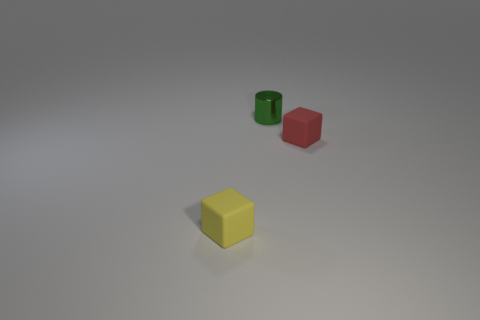What number of other things are the same shape as the green metallic thing?
Your answer should be very brief. 0. There is a object that is both in front of the cylinder and to the left of the small red rubber object; what size is it?
Your response must be concise. Small. The tiny shiny cylinder has what color?
Offer a terse response. Green. There is a rubber thing that is on the right side of the yellow rubber thing; is it the same shape as the green object behind the yellow rubber block?
Your answer should be very brief. No. What is the color of the matte block that is right of the small object that is behind the rubber thing to the right of the yellow rubber block?
Keep it short and to the point. Red. There is a small matte object behind the tiny yellow matte object; what is its color?
Your answer should be very brief. Red. What color is the cylinder that is the same size as the yellow thing?
Offer a very short reply. Green. Is the green metallic cylinder the same size as the yellow matte thing?
Make the answer very short. Yes. How many cubes are to the right of the yellow thing?
Give a very brief answer. 1. What number of objects are either things left of the green metallic thing or tiny green cylinders?
Your answer should be compact. 2. 